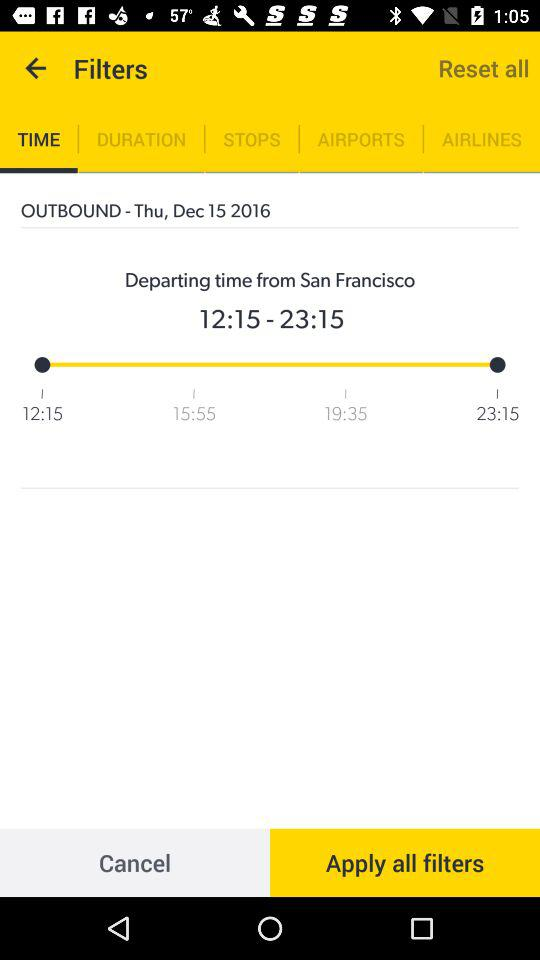What is the departing time from San Francisco? The departing time is from 12:15 to 23:15. 